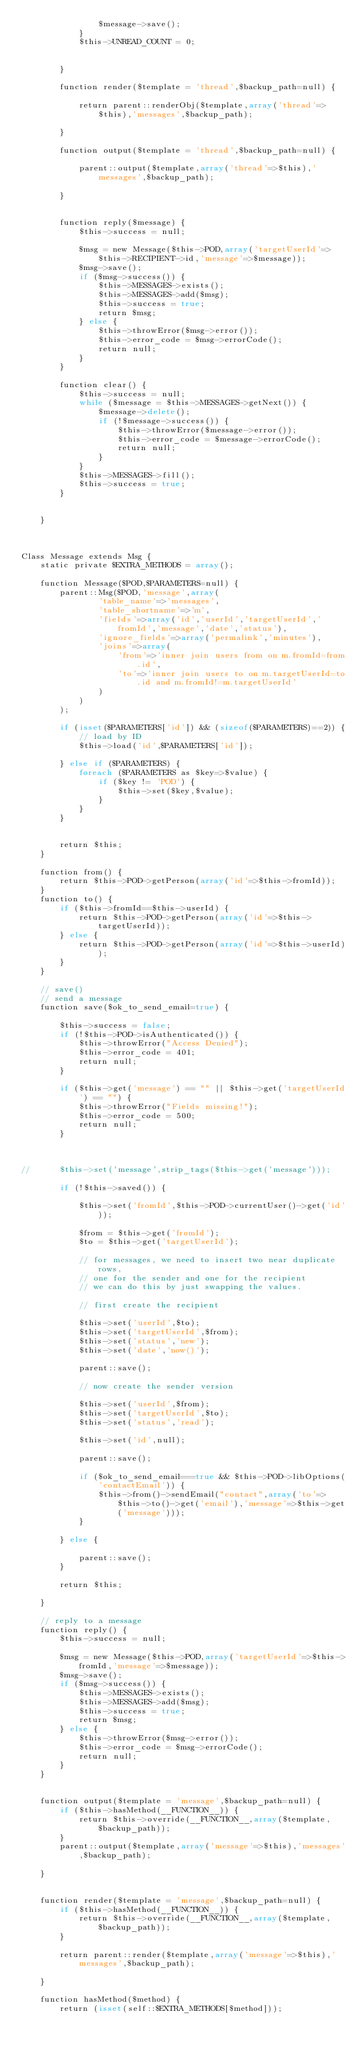<code> <loc_0><loc_0><loc_500><loc_500><_PHP_>				$message->save();
			}
			$this->UNREAD_COUNT = 0;
			
			
		}

		function render($template = 'thread',$backup_path=null) {
		
			return parent::renderObj($template,array('thread'=>$this),'messages',$backup_path);
	
		}
	
		function output($template = 'thread',$backup_path=null) {
		
			parent::output($template,array('thread'=>$this),'messages',$backup_path);
	
		}


		function reply($message) {
			$this->success = null;
			
			$msg = new Message($this->POD,array('targetUserId'=>$this->RECIPIENT->id,'message'=>$message));
			$msg->save();
			if ($msg->success()) { 
				$this->MESSAGES->exists();
				$this->MESSAGES->add($msg);
				$this->success = true;
				return $msg;		
			} else {
				$this->throwError($msg->error());
				$this->error_code = $msg->errorCode();
				return null;
			}	
		}
	
		function clear() {
			$this->success = null;
			while ($message = $this->MESSAGES->getNext()) { 
				$message->delete();
				if (!$message->success()) {
					$this->throwError($message->error());
					$this->error_code = $message->errorCode();
					return null;
				}
			}
			$this->MESSAGES->fill();
			$this->success = true;
		}
	
	
	}
	
	

Class Message extends Msg {
	static private $EXTRA_METHODS = array();

	function Message($POD,$PARAMETERS=null) { 
		parent::Msg($POD,'message',array(
				'table_name'=>'messages',
				'table_shortname'=>'m',
				'fields'=>array('id','userId','targetUserId','fromId','message','date','status'),
				'ignore_fields'=>array('permalink','minutes'),
				'joins'=>array(
					'from'=>'inner join users from on m.fromId=from.id',
					'to'=>'inner join users to on m.targetUserId=to.id and m.fromId!=m.targetUserId'
				)
			)
		);
		
		if (isset($PARAMETERS['id']) && (sizeof($PARAMETERS)==2)) { 
			// load by ID
			$this->load('id',$PARAMETERS['id']);							
		} else if ($PARAMETERS) {
			foreach ($PARAMETERS as $key=>$value) {
				if ($key != 'POD') {
					$this->set($key,$value);
				}
			}
		}


		return $this;
	}
	
	function from() {
		return $this->POD->getPerson(array('id'=>$this->fromId));
	}
	function to() {
		if ($this->fromId==$this->userId) { 
			return $this->POD->getPerson(array('id'=>$this->targetUserId));
		} else {
			return $this->POD->getPerson(array('id'=>$this->userId));		
		}
	}

	// save() 
	// send a message
	function save($ok_to_send_email=true) {
	
		$this->success = false;
		if (!$this->POD->isAuthenticated()) {
			$this->throwError("Access Denied");
			$this->error_code = 401;
			return null;
		}
		
		if ($this->get('message') == "" || $this->get('targetUserId') == "") {
			$this->throwError("Fields missing!");
			$this->error_code = 500;
			return null;
		}


	
//		$this->set('message',strip_tags($this->get('message')));
		
		if (!$this->saved()) { 
			
			$this->set('fromId',$this->POD->currentUser()->get('id'));
			
			$from = $this->get('fromId');
			$to = $this->get('targetUserId');
					
			// for messages, we need to insert two near duplicate rows,
			// one for the sender and one for the recipient
			// we can do this by just swapping the values.
			
			// first create the recipient

			$this->set('userId',$to);
			$this->set('targetUserId',$from);
			$this->set('status','new');
			$this->set('date','now()');

			parent::save();
			
			// now create the sender version
			
			$this->set('userId',$from);
			$this->set('targetUserId',$to);
			$this->set('status','read');
	  
			$this->set('id',null);

			parent::save();
			
			if ($ok_to_send_email===true && $this->POD->libOptions('contactEmail')) { 
				$this->from()->sendEmail("contact",array('to'=>$this->to()->get('email'),'message'=>$this->get('message')));
			}
		 	
		} else {
		
			parent::save();			
		}	 	

 		return $this;
	 	
	}
	
	// reply to a message
	function reply() {
		$this->success = null;
		
		$msg = new Message($this->POD,array('targetUserId'=>$this->fromId,'message'=>$message));
		$msg->save();
		if ($msg->success()) { 
			$this->MESSAGES->exists();
			$this->MESSAGES->add($msg);
			$this->success = true;
			return $msg;		
		} else {
			$this->throwError($msg->error());
			$this->error_code = $msg->errorCode();
			return null;
		}	
	}


	function output($template = 'message',$backup_path=null) {
		if ($this->hasMethod(__FUNCTION__)) { 
			return $this->override(__FUNCTION__,array($template,$backup_path));
		}
		parent::output($template,array('message'=>$this),'messages',$backup_path);

	}	


 	function render($template = 'message',$backup_path=null) {
		if ($this->hasMethod(__FUNCTION__)) { 
			return $this->override(__FUNCTION__,array($template,$backup_path));
		}
	
		return parent::render($template,array('message'=>$this),'messages',$backup_path);

	}
	
	function hasMethod($method) { 
		return (isset(self::$EXTRA_METHODS[$method]));		</code> 